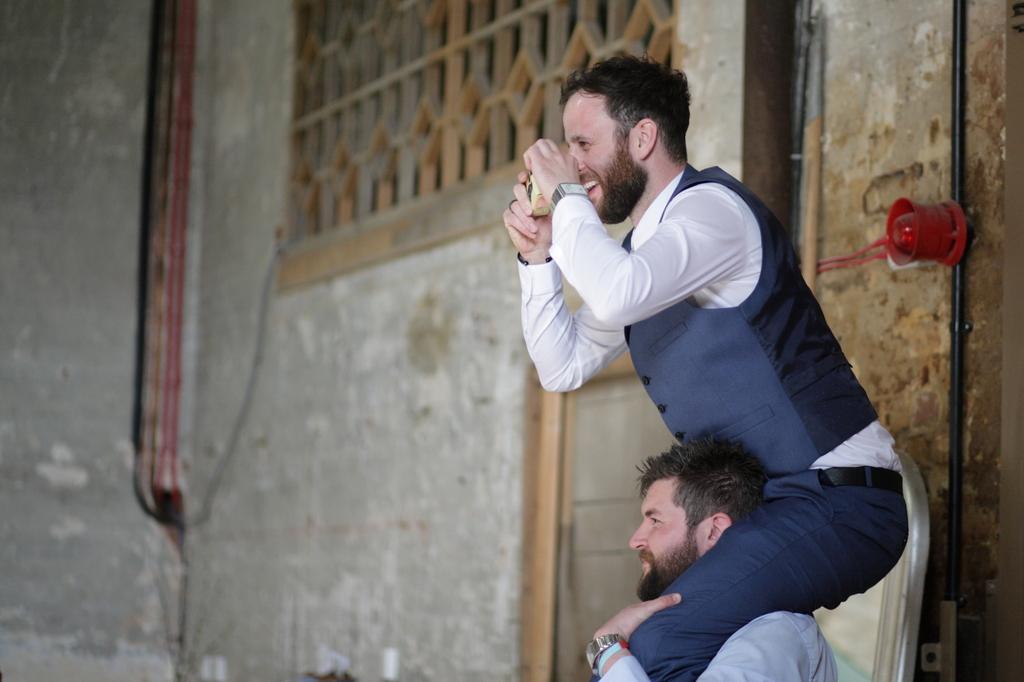Describe this image in one or two sentences. In this image a person is sitting on the other person. He is wearing a watch. This person is holding some device in his hand. Background there is wall having window and a door to it. 